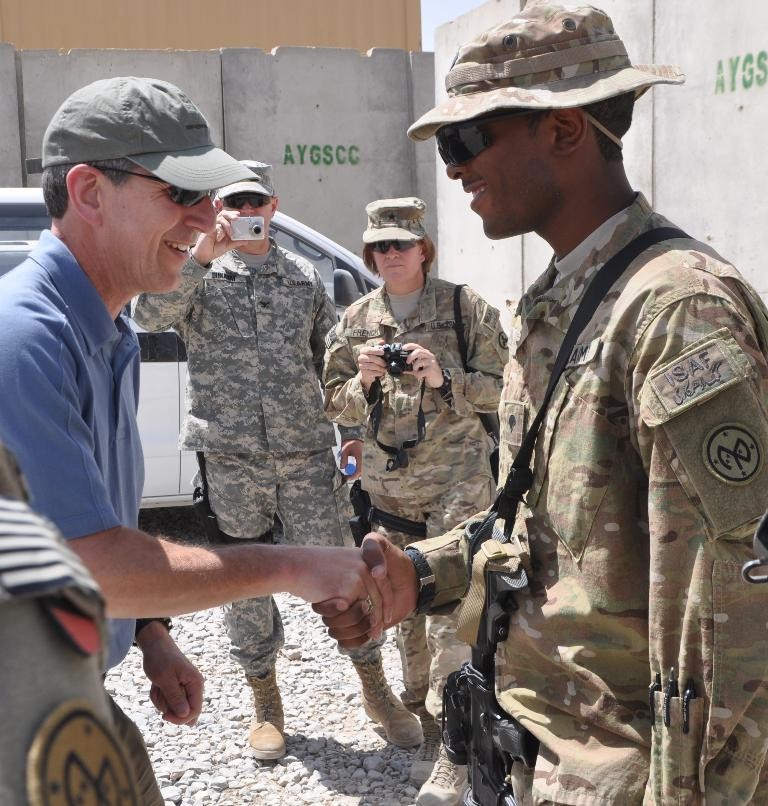What are the two persons in the foreground of the image doing? The two persons in the foreground of the image are standing and handshaking each other. What are the two persons in the background of the image doing? The two persons in the background of the image are standing and holding cameras. What can be seen in the background of the image? There is a white color car and a wall in the background of the image. What type of pan is being used by the man in the image? There is no pan present in the image. 